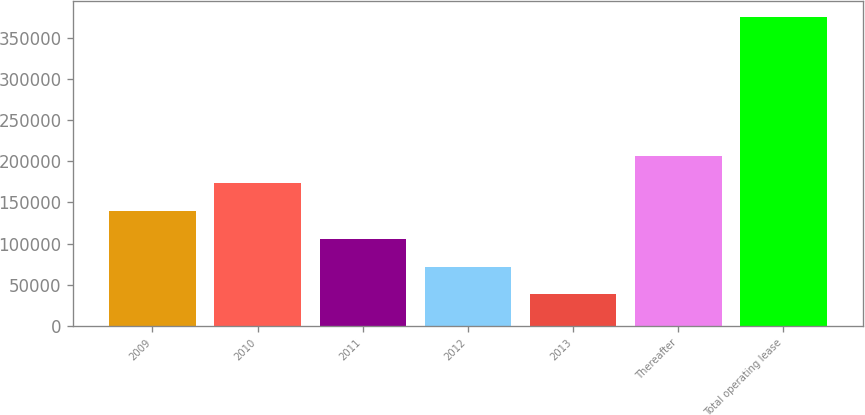Convert chart. <chart><loc_0><loc_0><loc_500><loc_500><bar_chart><fcel>2009<fcel>2010<fcel>2011<fcel>2012<fcel>2013<fcel>Thereafter<fcel>Total operating lease<nl><fcel>139593<fcel>173261<fcel>105924<fcel>72255.6<fcel>38587<fcel>206930<fcel>375273<nl></chart> 